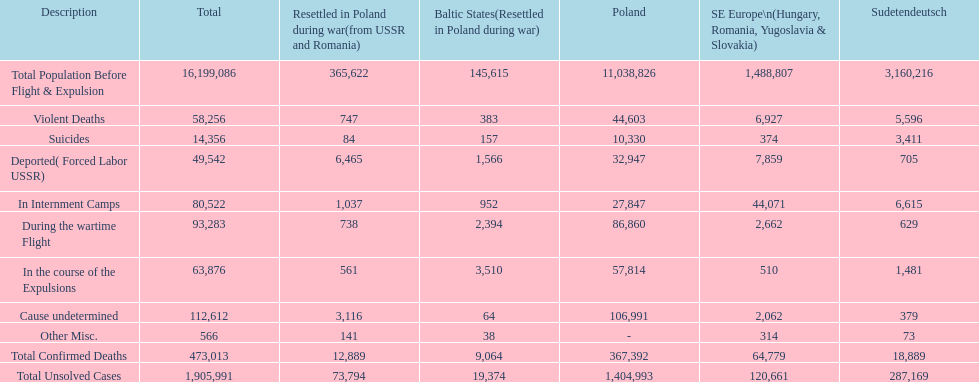Which zone had the lowest total of uncracked cases? Baltic States(Resettled in Poland during war). Can you parse all the data within this table? {'header': ['Description', 'Total', 'Resettled in Poland during war(from USSR and Romania)', 'Baltic States(Resettled in Poland during war)', 'Poland', 'SE Europe\\n(Hungary, Romania, Yugoslavia & Slovakia)', 'Sudetendeutsch'], 'rows': [['Total Population Before Flight & Expulsion', '16,199,086', '365,622', '145,615', '11,038,826', '1,488,807', '3,160,216'], ['Violent Deaths', '58,256', '747', '383', '44,603', '6,927', '5,596'], ['Suicides', '14,356', '84', '157', '10,330', '374', '3,411'], ['Deported( Forced Labor USSR)', '49,542', '6,465', '1,566', '32,947', '7,859', '705'], ['In Internment Camps', '80,522', '1,037', '952', '27,847', '44,071', '6,615'], ['During the wartime Flight', '93,283', '738', '2,394', '86,860', '2,662', '629'], ['In the course of the Expulsions', '63,876', '561', '3,510', '57,814', '510', '1,481'], ['Cause undetermined', '112,612', '3,116', '64', '106,991', '2,062', '379'], ['Other Misc.', '566', '141', '38', '-', '314', '73'], ['Total Confirmed Deaths', '473,013', '12,889', '9,064', '367,392', '64,779', '18,889'], ['Total Unsolved Cases', '1,905,991', '73,794', '19,374', '1,404,993', '120,661', '287,169']]} 